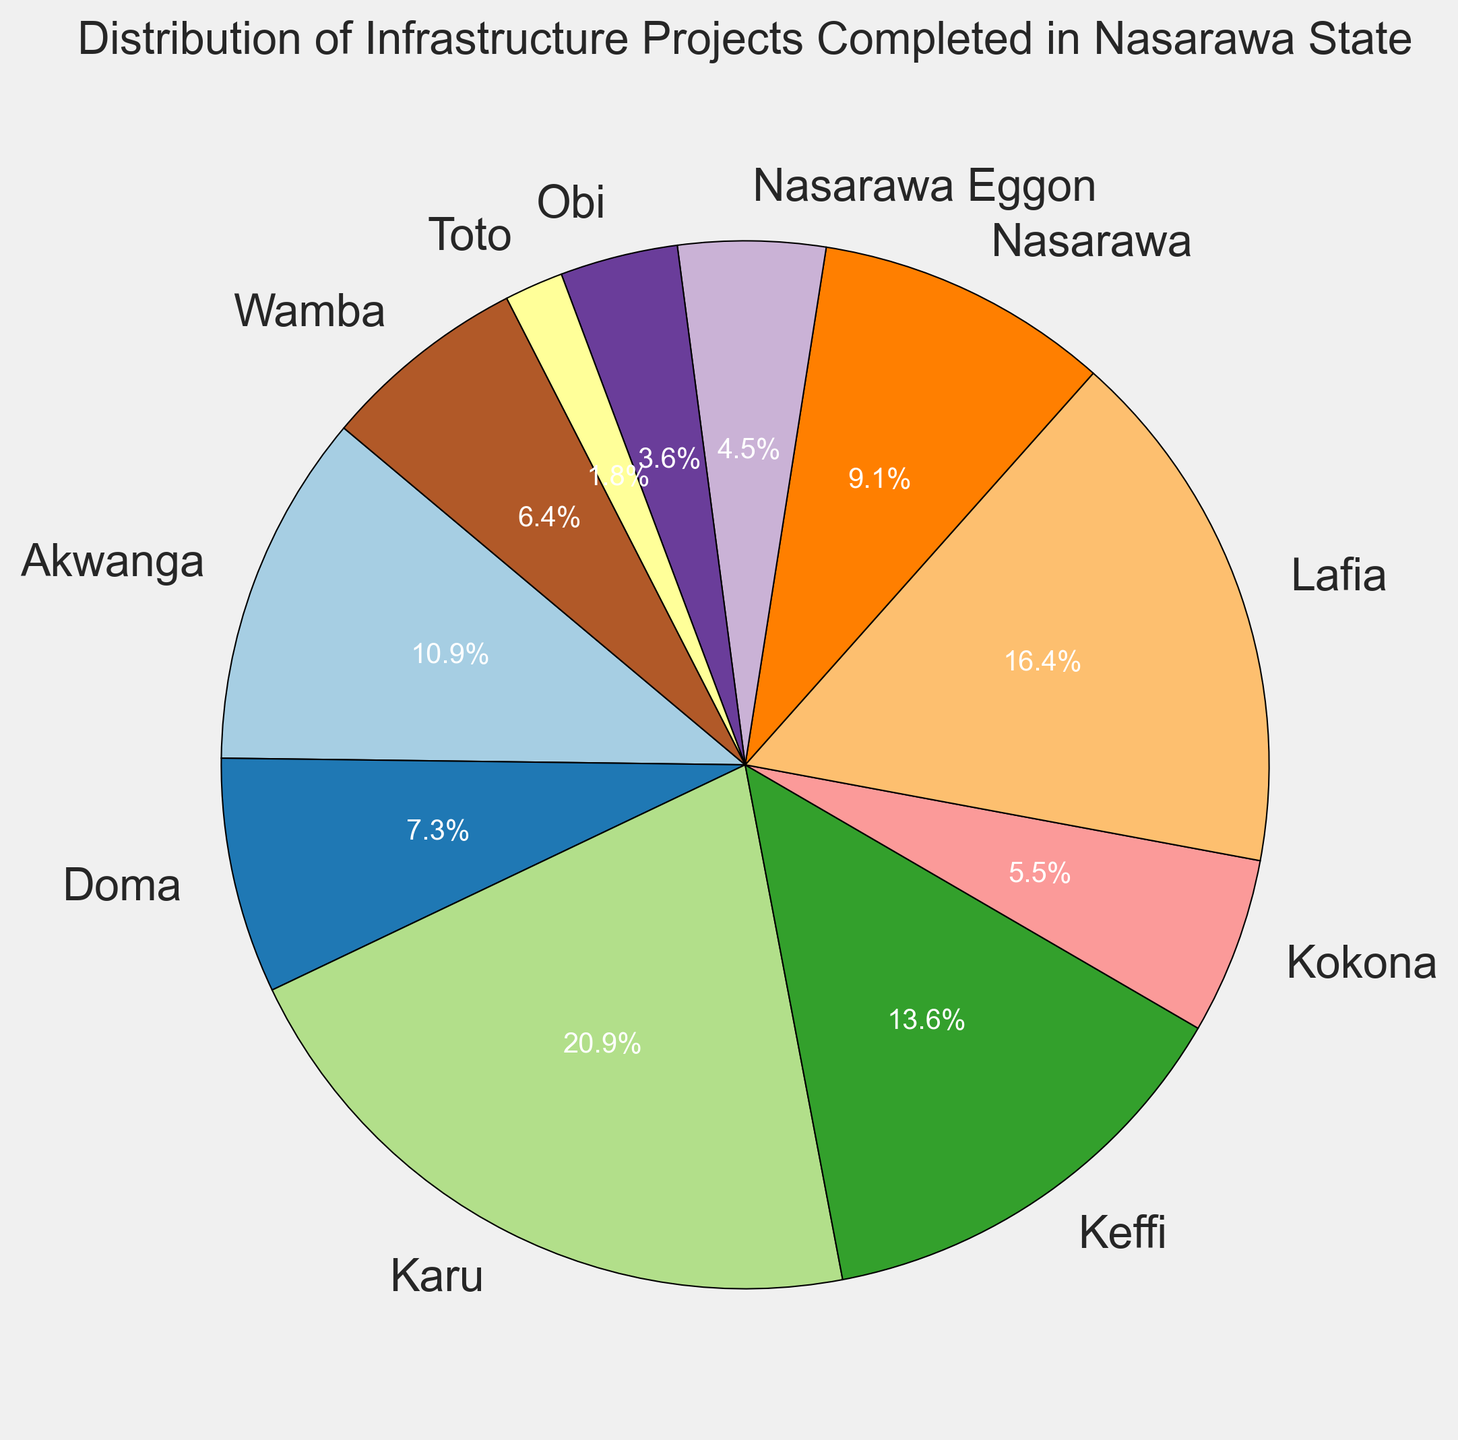What is the percentage of completed projects in Karu? Karu is one of the wedges in the pie chart, and the label on the pie chart shows the percentage. By looking at the chart, we can directly read the percentage.
Answer: 23.8% Which local government area has the highest number of completed projects? The pie chart's largest wedge represents the local government with the highest number of completed projects.
Answer: Karu How many more projects were completed in Lafia compared to Doma? Find the wedges representing Lafia and Doma, subtract Doma's number from Lafia's to get the difference. Lafia has 18, and Doma has 8 completed projects. 18 - 8 = 10
Answer: 10 What is the combined percentage of completed projects in Keffi and Akwanga? Locate the wedges for Keffi and Akwanga, read the percentages, and sum them. Keffi is 17.9%, and Akwanga is 14.3%, so 17.9% + 14.3% = 32.2%
Answer: 32.2% Which local government areas have fewer completed projects than Nasarawa? Examine the wedges and compare their sizes to Nasarawa's, which has completed 10 projects. The areas with fewer projects are Doma (8), Wamba (7), Kokona (6), Nasarawa Eggon (5), Obi (4), Karu (3), and Toto (2).
Answer: Doma, Wamba, Kokona, Nasarawa Eggon, Obi, Karu, Toto What is the average number of completed projects across four randomly chosen local government areas: Toto, Obi, Doma, and Akwanga? Sum the number of completed projects in these areas and divide by 4. Toto has 2, Obi 4, Doma 8, and Akwanga 12 projects. The sum is 2 + 4 + 8 + 12 = 26. The average is 26 / 4 = 6.5
Answer: 6.5 Which color represents the local government area with the second-highest completion rate? Identify the wedge with the second largest size and note its color. The local government area with the second-highest completion rate is Lafia. The pie wedge representing Lafia is green.
Answer: Green List the local government areas in descending order based on completed projects. Look at the sizes of the wedges and sort them accordingly from largest to smallest. The order is Karu (23.8%), Lafia (21.4%), Keffi (17.9%), Akwanga (14.3%), Nasarawa (11.9%), Doma (9.5%), Wamba (8.3%), Kokona (7.1%), Nasarawa Eggon (6.0%), Obi (4.8%), Karu (3.6%), Toto (2.4%).
Answer: Karu, Lafia, Keffi, Akwanga, Nasarawa, Doma, Wamba, Kokona, Nasarawa Eggon, Obi, Karu, Toto What is the total number of completed projects across all local government areas? Sum the number of completed projects from all local government areas. Karu (20+3), Lafia (18), Keffi (15), Akwanga (12), Nasarawa (10), Doma (8), Wamba (7), Kokona (6), Nasarawa Eggon (5), Obi (4), Toto (2). The total is 20+3+18+15+12+10+8+7+6+5+4+2 = 110.
Answer: 110 